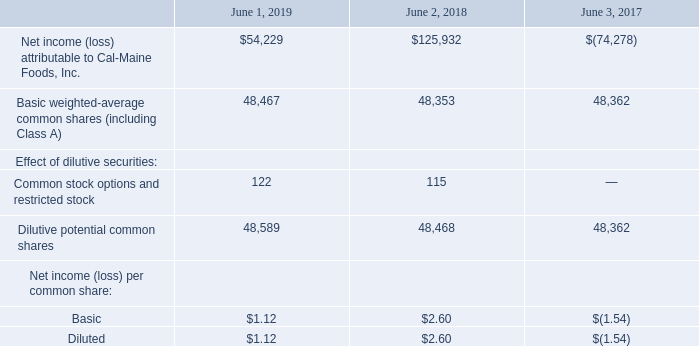Net Income (Loss) per Common Share
Basic net income per share is based on the weighted average common and Class A shares outstanding. Diluted net income per share includes any dilutive effects of stock options outstanding and unvested restricted shares.
Basic net income per share was calculated by dividing net income by the weighted-average number of common and Class A shares outstanding during the period. Diluted net income per share was calculated by dividing net income by the weighted-average number of common shares outstanding during the period plus the dilutive effects of stock options and unvested restricted shares. Due to the net loss in the year ended June 3, 2017 restricted shares in the amount of 131,292 were excluded from the calculation of diluted earnings per share because their inclusion would have been
antidilutive. The computations of basic net income per share and diluted net income per share are as follows (in thousands):
What is the increase in net income (loss) from 2018 to 2019?
Answer scale should be: thousand. 54,229 - 125,932
Answer: -71703. What is the number of common shares in the market in June 2019? 48,467. How is the diluted net income per share calculated? Net income per share was calculated by dividing net income by the weighted-average number of common shares outstanding during the period plus the dilutive effects of stock options and unvested restricted shares. What is the number of common and restricted stock option in 2019? 122. What is the average of the last 3 years basic net income per common share?
Answer scale should be: thousand. (1.12 + 2.60 - 1.54) / 3
Answer: 0.73. What is the increase / decrease in the number of dilutive potential common shares from 2018 to 2019? 48,589 - 48,468
Answer: 121. 